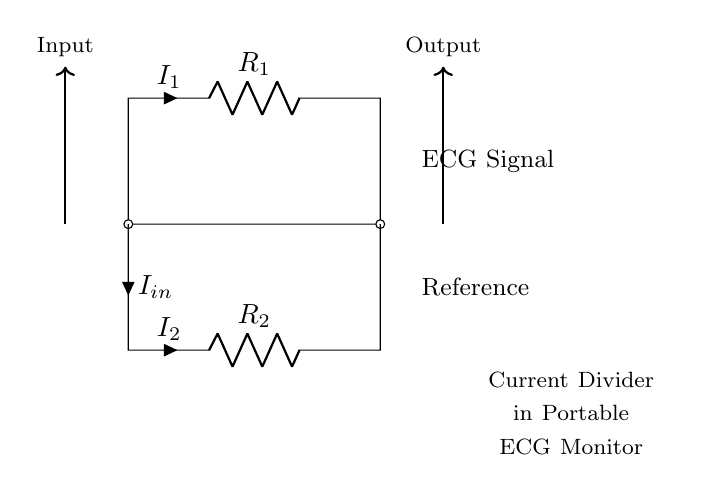What is the type of the circuit shown? The circuit is a current divider, which splits the input current into two output currents through two resistors. The arrangement of the resistors in parallel confirms this classification.
Answer: current divider What are the resistances in the circuit? The circuit features two resistors labeled as R1 and R2. Their specific resistance values are not provided in the diagram; they are simply represented generically.
Answer: R1, R2 How many input and output currents are shown? The circuit shows one input current, labeled I-in, and two output currents, labeled I1 and I2, indicating the division of the total current through the resistors.
Answer: one input, two outputs What does I1 represent? I1 represents the current passing through the resistor R1 in the upper branch of the current divider. It indicates how much of the input current flows through this particular path.
Answer: current through R1 What is the relationship between I-in, I1, and I2? The relationship is defined by the equation I-in equals the sum of I1 and I2. This indicates that the total input current is distributed among the two output branches.
Answer: I-in = I1 + I2 How does the current divider help in an ECG monitor? The current divider allows for accurate measurement of the ECG signal by directing a controlled proportion of the input current through different paths, facilitating precise signal processing and referencing.
Answer: accurate measurement What could happen if R1 and R2 have significantly different values? If R1 and R2 have significantly different values, most of the input current will preferentially pass through the path with the lower resistance, causing an imbalance in current distribution that might affect the ECG readings.
Answer: imbalance in current 